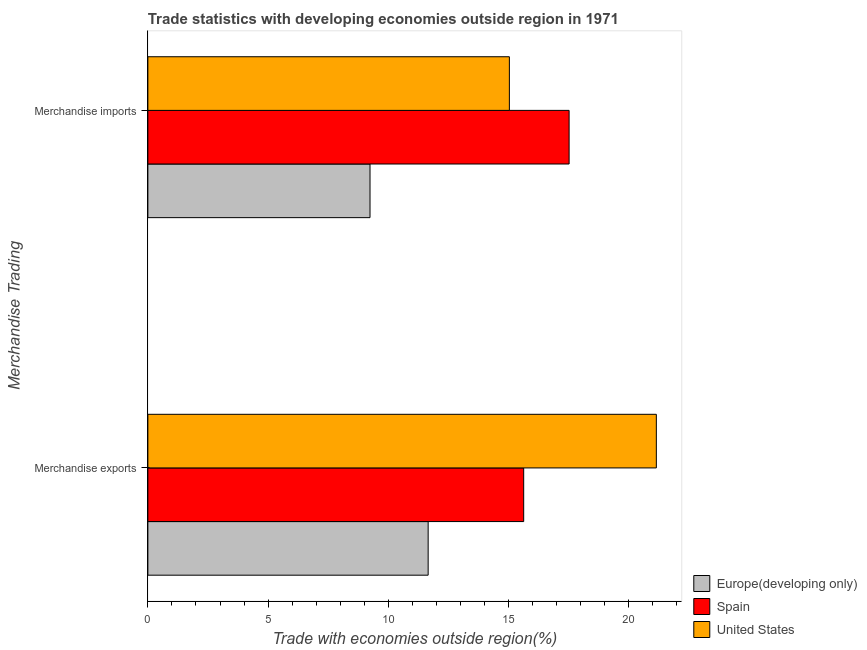How many different coloured bars are there?
Make the answer very short. 3. How many groups of bars are there?
Give a very brief answer. 2. How many bars are there on the 1st tick from the bottom?
Provide a succinct answer. 3. What is the label of the 1st group of bars from the top?
Your answer should be compact. Merchandise imports. What is the merchandise imports in Europe(developing only)?
Give a very brief answer. 9.24. Across all countries, what is the maximum merchandise exports?
Offer a very short reply. 21.14. Across all countries, what is the minimum merchandise imports?
Offer a very short reply. 9.24. In which country was the merchandise imports minimum?
Offer a terse response. Europe(developing only). What is the total merchandise imports in the graph?
Keep it short and to the point. 41.79. What is the difference between the merchandise exports in Spain and that in United States?
Provide a short and direct response. -5.52. What is the difference between the merchandise imports in Spain and the merchandise exports in United States?
Keep it short and to the point. -3.63. What is the average merchandise exports per country?
Your answer should be very brief. 16.14. What is the difference between the merchandise exports and merchandise imports in Europe(developing only)?
Give a very brief answer. 2.42. In how many countries, is the merchandise exports greater than 17 %?
Keep it short and to the point. 1. What is the ratio of the merchandise imports in Europe(developing only) to that in Spain?
Your answer should be compact. 0.53. In how many countries, is the merchandise imports greater than the average merchandise imports taken over all countries?
Give a very brief answer. 2. What does the 1st bar from the top in Merchandise imports represents?
Provide a succinct answer. United States. What does the 3rd bar from the bottom in Merchandise exports represents?
Your answer should be very brief. United States. How many bars are there?
Ensure brevity in your answer.  6. Does the graph contain grids?
Provide a succinct answer. No. How are the legend labels stacked?
Offer a very short reply. Vertical. What is the title of the graph?
Provide a succinct answer. Trade statistics with developing economies outside region in 1971. What is the label or title of the X-axis?
Your answer should be very brief. Trade with economies outside region(%). What is the label or title of the Y-axis?
Provide a short and direct response. Merchandise Trading. What is the Trade with economies outside region(%) in Europe(developing only) in Merchandise exports?
Give a very brief answer. 11.66. What is the Trade with economies outside region(%) of Spain in Merchandise exports?
Your answer should be very brief. 15.63. What is the Trade with economies outside region(%) of United States in Merchandise exports?
Keep it short and to the point. 21.14. What is the Trade with economies outside region(%) in Europe(developing only) in Merchandise imports?
Your response must be concise. 9.24. What is the Trade with economies outside region(%) of Spain in Merchandise imports?
Give a very brief answer. 17.52. What is the Trade with economies outside region(%) in United States in Merchandise imports?
Provide a succinct answer. 15.03. Across all Merchandise Trading, what is the maximum Trade with economies outside region(%) in Europe(developing only)?
Keep it short and to the point. 11.66. Across all Merchandise Trading, what is the maximum Trade with economies outside region(%) of Spain?
Provide a short and direct response. 17.52. Across all Merchandise Trading, what is the maximum Trade with economies outside region(%) in United States?
Offer a very short reply. 21.14. Across all Merchandise Trading, what is the minimum Trade with economies outside region(%) of Europe(developing only)?
Your response must be concise. 9.24. Across all Merchandise Trading, what is the minimum Trade with economies outside region(%) in Spain?
Keep it short and to the point. 15.63. Across all Merchandise Trading, what is the minimum Trade with economies outside region(%) of United States?
Provide a succinct answer. 15.03. What is the total Trade with economies outside region(%) in Europe(developing only) in the graph?
Offer a terse response. 20.89. What is the total Trade with economies outside region(%) of Spain in the graph?
Your answer should be compact. 33.14. What is the total Trade with economies outside region(%) of United States in the graph?
Provide a short and direct response. 36.18. What is the difference between the Trade with economies outside region(%) in Europe(developing only) in Merchandise exports and that in Merchandise imports?
Your answer should be very brief. 2.42. What is the difference between the Trade with economies outside region(%) of Spain in Merchandise exports and that in Merchandise imports?
Your response must be concise. -1.89. What is the difference between the Trade with economies outside region(%) in United States in Merchandise exports and that in Merchandise imports?
Keep it short and to the point. 6.11. What is the difference between the Trade with economies outside region(%) of Europe(developing only) in Merchandise exports and the Trade with economies outside region(%) of Spain in Merchandise imports?
Make the answer very short. -5.86. What is the difference between the Trade with economies outside region(%) of Europe(developing only) in Merchandise exports and the Trade with economies outside region(%) of United States in Merchandise imports?
Your answer should be very brief. -3.38. What is the difference between the Trade with economies outside region(%) in Spain in Merchandise exports and the Trade with economies outside region(%) in United States in Merchandise imports?
Provide a short and direct response. 0.6. What is the average Trade with economies outside region(%) in Europe(developing only) per Merchandise Trading?
Provide a succinct answer. 10.45. What is the average Trade with economies outside region(%) in Spain per Merchandise Trading?
Offer a terse response. 16.57. What is the average Trade with economies outside region(%) of United States per Merchandise Trading?
Your answer should be very brief. 18.09. What is the difference between the Trade with economies outside region(%) in Europe(developing only) and Trade with economies outside region(%) in Spain in Merchandise exports?
Your answer should be compact. -3.97. What is the difference between the Trade with economies outside region(%) in Europe(developing only) and Trade with economies outside region(%) in United States in Merchandise exports?
Your answer should be compact. -9.49. What is the difference between the Trade with economies outside region(%) in Spain and Trade with economies outside region(%) in United States in Merchandise exports?
Provide a succinct answer. -5.52. What is the difference between the Trade with economies outside region(%) in Europe(developing only) and Trade with economies outside region(%) in Spain in Merchandise imports?
Offer a terse response. -8.28. What is the difference between the Trade with economies outside region(%) in Europe(developing only) and Trade with economies outside region(%) in United States in Merchandise imports?
Provide a succinct answer. -5.79. What is the difference between the Trade with economies outside region(%) of Spain and Trade with economies outside region(%) of United States in Merchandise imports?
Make the answer very short. 2.48. What is the ratio of the Trade with economies outside region(%) of Europe(developing only) in Merchandise exports to that in Merchandise imports?
Offer a terse response. 1.26. What is the ratio of the Trade with economies outside region(%) of Spain in Merchandise exports to that in Merchandise imports?
Offer a very short reply. 0.89. What is the ratio of the Trade with economies outside region(%) of United States in Merchandise exports to that in Merchandise imports?
Provide a succinct answer. 1.41. What is the difference between the highest and the second highest Trade with economies outside region(%) of Europe(developing only)?
Provide a succinct answer. 2.42. What is the difference between the highest and the second highest Trade with economies outside region(%) of Spain?
Give a very brief answer. 1.89. What is the difference between the highest and the second highest Trade with economies outside region(%) in United States?
Your answer should be very brief. 6.11. What is the difference between the highest and the lowest Trade with economies outside region(%) of Europe(developing only)?
Your response must be concise. 2.42. What is the difference between the highest and the lowest Trade with economies outside region(%) of Spain?
Make the answer very short. 1.89. What is the difference between the highest and the lowest Trade with economies outside region(%) of United States?
Offer a very short reply. 6.11. 